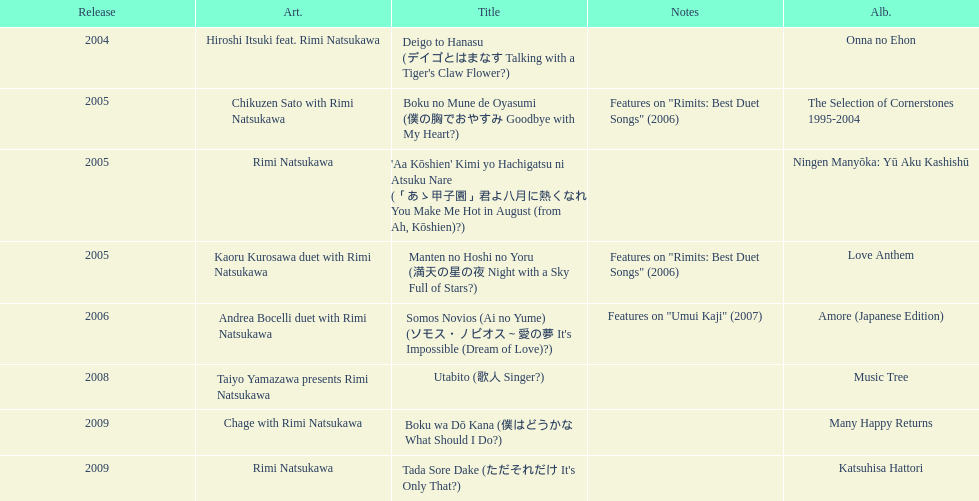How many titles have only one artist? 2. 